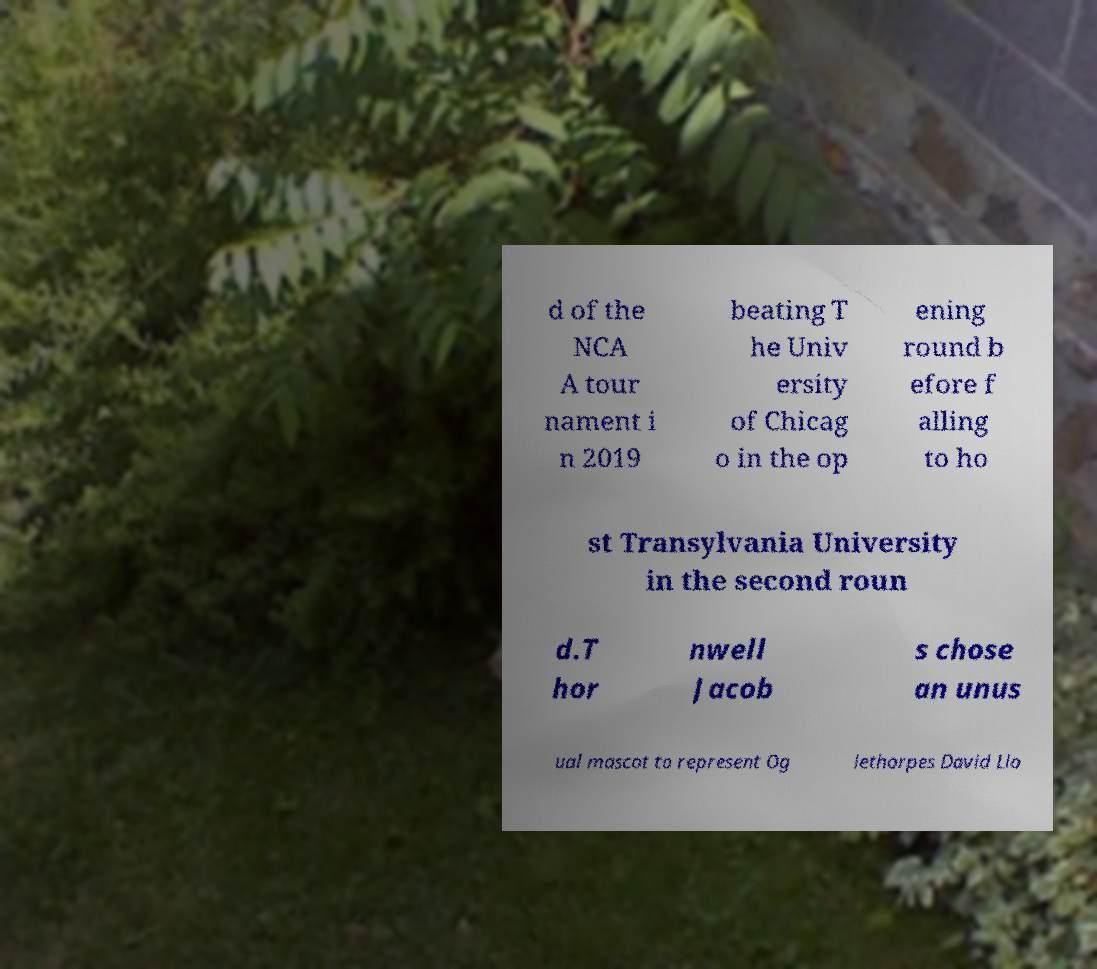Could you extract and type out the text from this image? d of the NCA A tour nament i n 2019 beating T he Univ ersity of Chicag o in the op ening round b efore f alling to ho st Transylvania University in the second roun d.T hor nwell Jacob s chose an unus ual mascot to represent Og lethorpes David Llo 